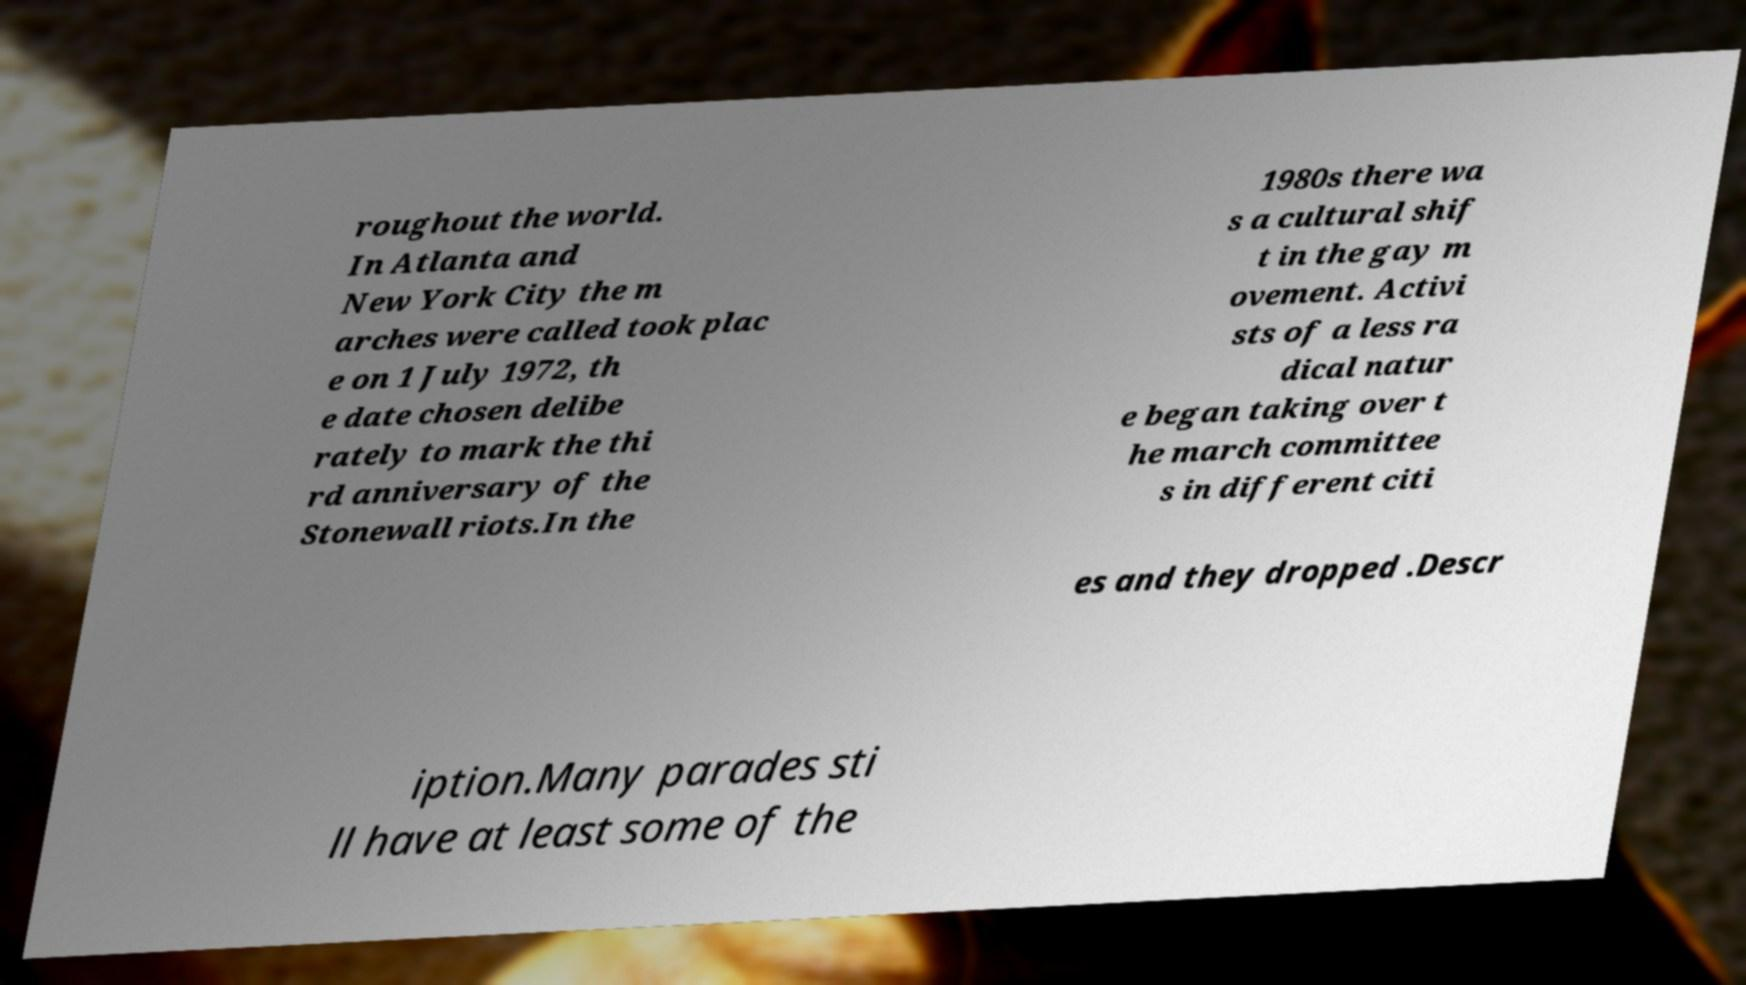What messages or text are displayed in this image? I need them in a readable, typed format. roughout the world. In Atlanta and New York City the m arches were called took plac e on 1 July 1972, th e date chosen delibe rately to mark the thi rd anniversary of the Stonewall riots.In the 1980s there wa s a cultural shif t in the gay m ovement. Activi sts of a less ra dical natur e began taking over t he march committee s in different citi es and they dropped .Descr iption.Many parades sti ll have at least some of the 